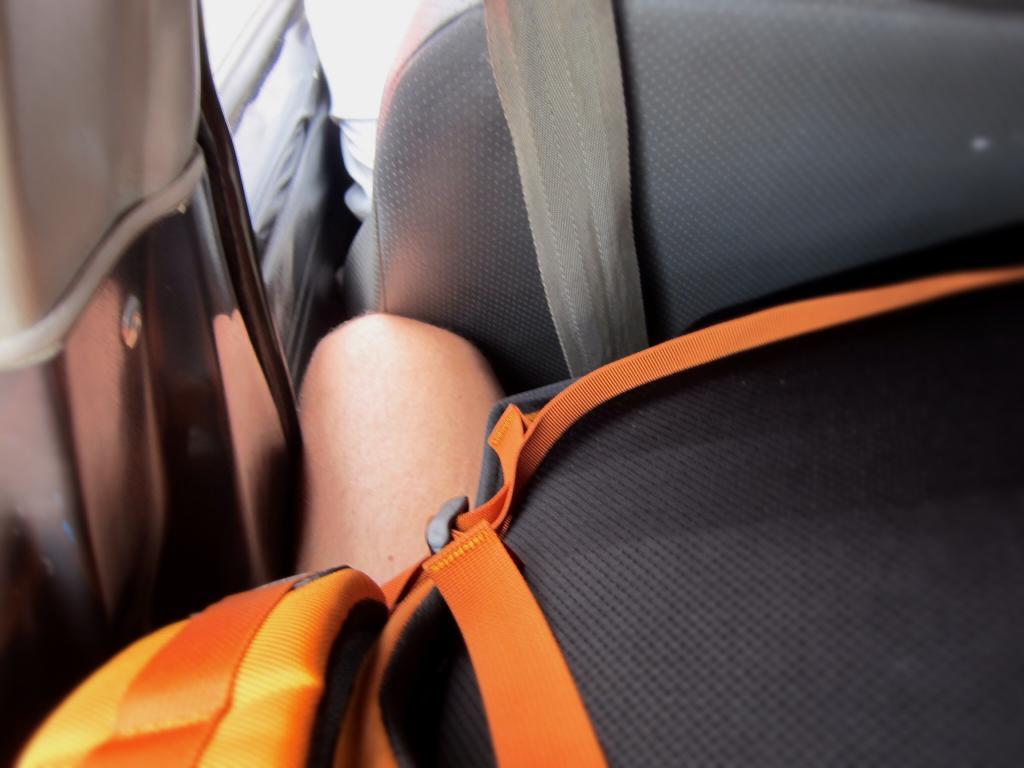In one or two sentences, can you explain what this image depicts? In the image inside the car there is a person leg with black and orange color bag. Behind the leg there is a seat and a seat belt.  